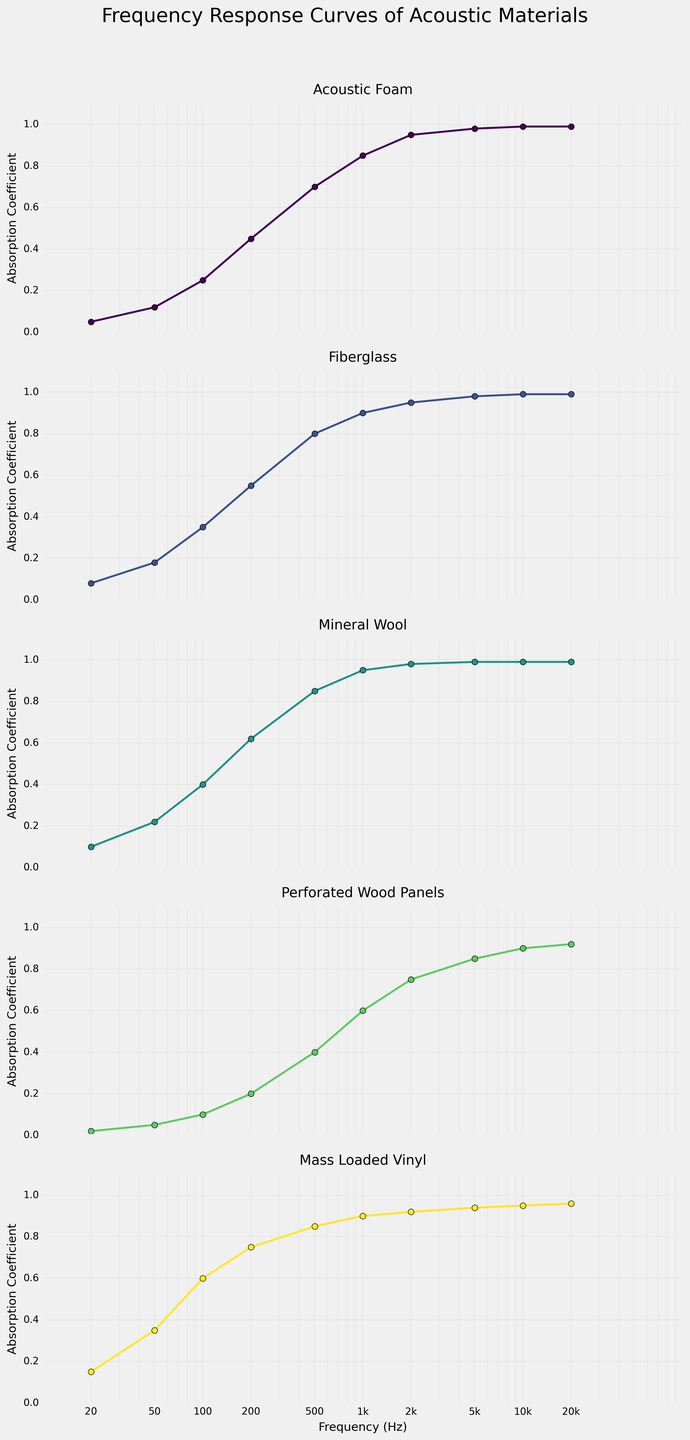Which material shows the highest absorption coefficient at 1000 Hz? By examining the subplots, we can compare the absorption coefficients at 1000 Hz. The highest absorption coefficient at this frequency is shown by Mineral Wool, with a value of 0.95.
Answer: Mineral Wool Which material has the lowest absorption coefficient at 20 Hz? Looking at the subplots for each material, we find that Perforated Wood Panels show the lowest absorption coefficient at 20 Hz, with a value of 0.02.
Answer: Perforated Wood Panels How does the absorption coefficient of Mass Loaded Vinyl change from 20 Hz to 200 Hz? Observing the subplot for Mass Loaded Vinyl, the absorption coefficient increases from 0.15 at 20 Hz to 0.75 at 200 Hz.
Answer: Increases What is the average absorption coefficient of Acoustic Foam across all frequencies? To find the average, sum up the absorption coefficients of Acoustic Foam at all frequencies and divide by the number of data points. (0.05 + 0.12 + 0.25 + 0.45 + 0.70 + 0.85 + 0.95 + 0.98 + 0.99 + 0.99) / 10 = 0.633
Answer: 0.63 At what frequency does Fiberglass first reach an absorption coefficient of 0.9? By inspecting the subplot for Fiberglass, we see that it first reaches an absorption coefficient of 0.9 at 1000 Hz.
Answer: 1000 Hz Which material has the steepest increase in absorption coefficient between 20 Hz and 50 Hz? To determine this, we calculate the change in absorption coefficient for each material between 20 Hz and 50 Hz. The steepest increase is exhibited by Mass Loaded Vinyl, where the coefficient changes from 0.15 to 0.35.
Answer: Mass Loaded Vinyl Do any materials have an absorption coefficient of 1.0 at any frequency within the range? Observing the subplots, none of the materials reach exactly 1.0 at any given frequency.
Answer: No Compare the absorption coefficients of Acoustic Foam and Fiberglass at 5000 Hz. Which one is higher? At 5000 Hz, the absorption coefficient for both Acoustic Foam and Fiberglass is 0.98, making them equal.
Answer: Equal What is the difference in absorption coefficient between Perforated Wood Panels and Mineral Wool at 100 Hz? Subtract the absorption coefficient of Perforated Wood Panels from that of Mineral Wool at 100 Hz. 0.40 (Mineral Wool) - 0.10 (Perforated Wood Panels) = 0.30
Answer: 0.30 At which frequency do all materials show an absorption coefficient above 0.5? By analyzing the subplots, all materials have an absorption coefficient above 0.5 at 500 Hz and higher frequencies.
Answer: 500 Hz and higher 